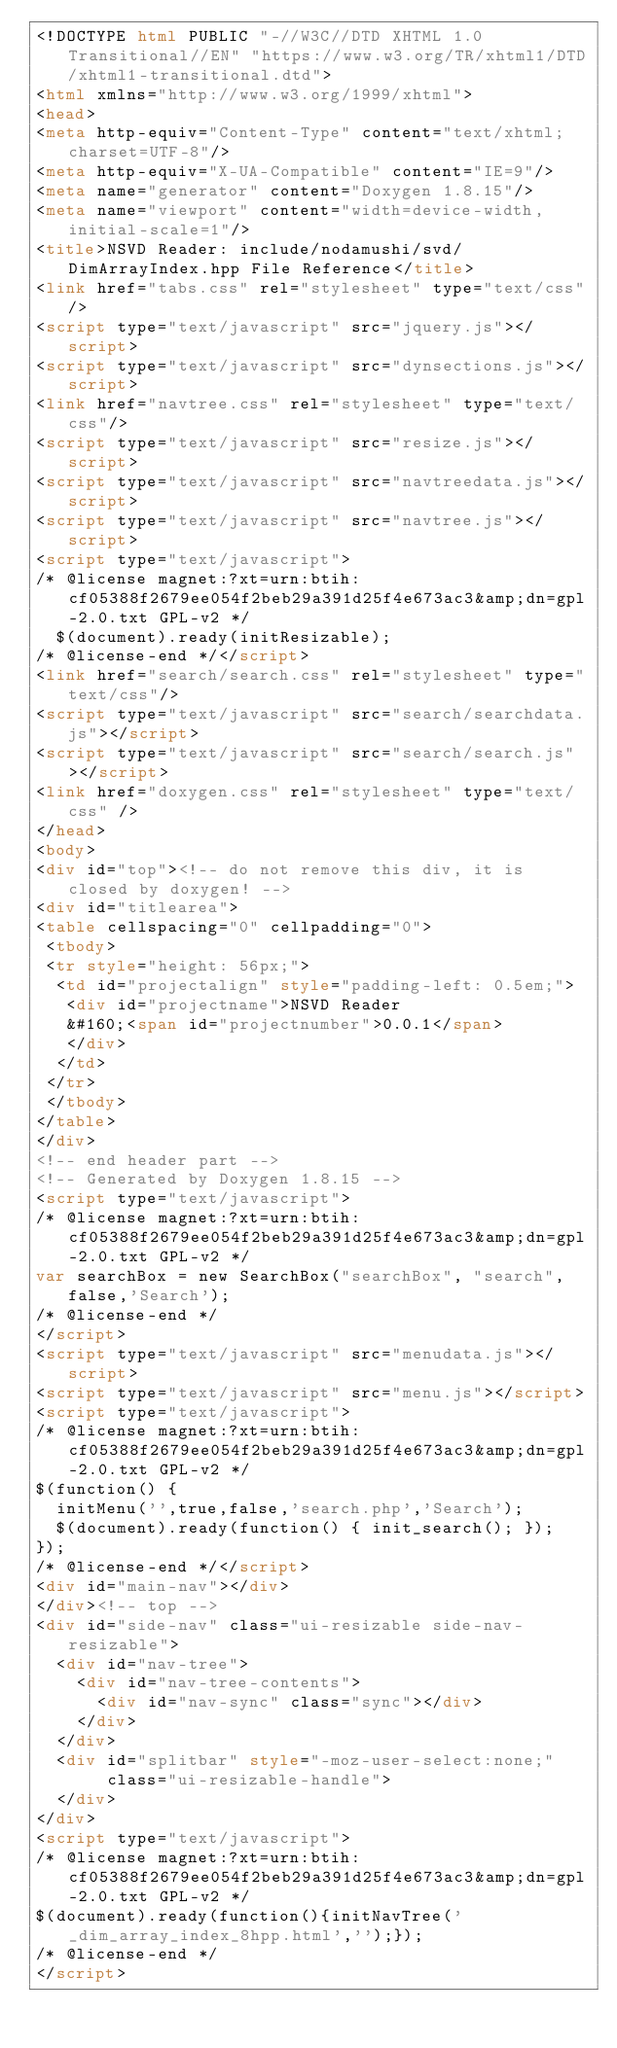<code> <loc_0><loc_0><loc_500><loc_500><_HTML_><!DOCTYPE html PUBLIC "-//W3C//DTD XHTML 1.0 Transitional//EN" "https://www.w3.org/TR/xhtml1/DTD/xhtml1-transitional.dtd">
<html xmlns="http://www.w3.org/1999/xhtml">
<head>
<meta http-equiv="Content-Type" content="text/xhtml;charset=UTF-8"/>
<meta http-equiv="X-UA-Compatible" content="IE=9"/>
<meta name="generator" content="Doxygen 1.8.15"/>
<meta name="viewport" content="width=device-width, initial-scale=1"/>
<title>NSVD Reader: include/nodamushi/svd/DimArrayIndex.hpp File Reference</title>
<link href="tabs.css" rel="stylesheet" type="text/css"/>
<script type="text/javascript" src="jquery.js"></script>
<script type="text/javascript" src="dynsections.js"></script>
<link href="navtree.css" rel="stylesheet" type="text/css"/>
<script type="text/javascript" src="resize.js"></script>
<script type="text/javascript" src="navtreedata.js"></script>
<script type="text/javascript" src="navtree.js"></script>
<script type="text/javascript">
/* @license magnet:?xt=urn:btih:cf05388f2679ee054f2beb29a391d25f4e673ac3&amp;dn=gpl-2.0.txt GPL-v2 */
  $(document).ready(initResizable);
/* @license-end */</script>
<link href="search/search.css" rel="stylesheet" type="text/css"/>
<script type="text/javascript" src="search/searchdata.js"></script>
<script type="text/javascript" src="search/search.js"></script>
<link href="doxygen.css" rel="stylesheet" type="text/css" />
</head>
<body>
<div id="top"><!-- do not remove this div, it is closed by doxygen! -->
<div id="titlearea">
<table cellspacing="0" cellpadding="0">
 <tbody>
 <tr style="height: 56px;">
  <td id="projectalign" style="padding-left: 0.5em;">
   <div id="projectname">NSVD Reader
   &#160;<span id="projectnumber">0.0.1</span>
   </div>
  </td>
 </tr>
 </tbody>
</table>
</div>
<!-- end header part -->
<!-- Generated by Doxygen 1.8.15 -->
<script type="text/javascript">
/* @license magnet:?xt=urn:btih:cf05388f2679ee054f2beb29a391d25f4e673ac3&amp;dn=gpl-2.0.txt GPL-v2 */
var searchBox = new SearchBox("searchBox", "search",false,'Search');
/* @license-end */
</script>
<script type="text/javascript" src="menudata.js"></script>
<script type="text/javascript" src="menu.js"></script>
<script type="text/javascript">
/* @license magnet:?xt=urn:btih:cf05388f2679ee054f2beb29a391d25f4e673ac3&amp;dn=gpl-2.0.txt GPL-v2 */
$(function() {
  initMenu('',true,false,'search.php','Search');
  $(document).ready(function() { init_search(); });
});
/* @license-end */</script>
<div id="main-nav"></div>
</div><!-- top -->
<div id="side-nav" class="ui-resizable side-nav-resizable">
  <div id="nav-tree">
    <div id="nav-tree-contents">
      <div id="nav-sync" class="sync"></div>
    </div>
  </div>
  <div id="splitbar" style="-moz-user-select:none;" 
       class="ui-resizable-handle">
  </div>
</div>
<script type="text/javascript">
/* @license magnet:?xt=urn:btih:cf05388f2679ee054f2beb29a391d25f4e673ac3&amp;dn=gpl-2.0.txt GPL-v2 */
$(document).ready(function(){initNavTree('_dim_array_index_8hpp.html','');});
/* @license-end */
</script></code> 